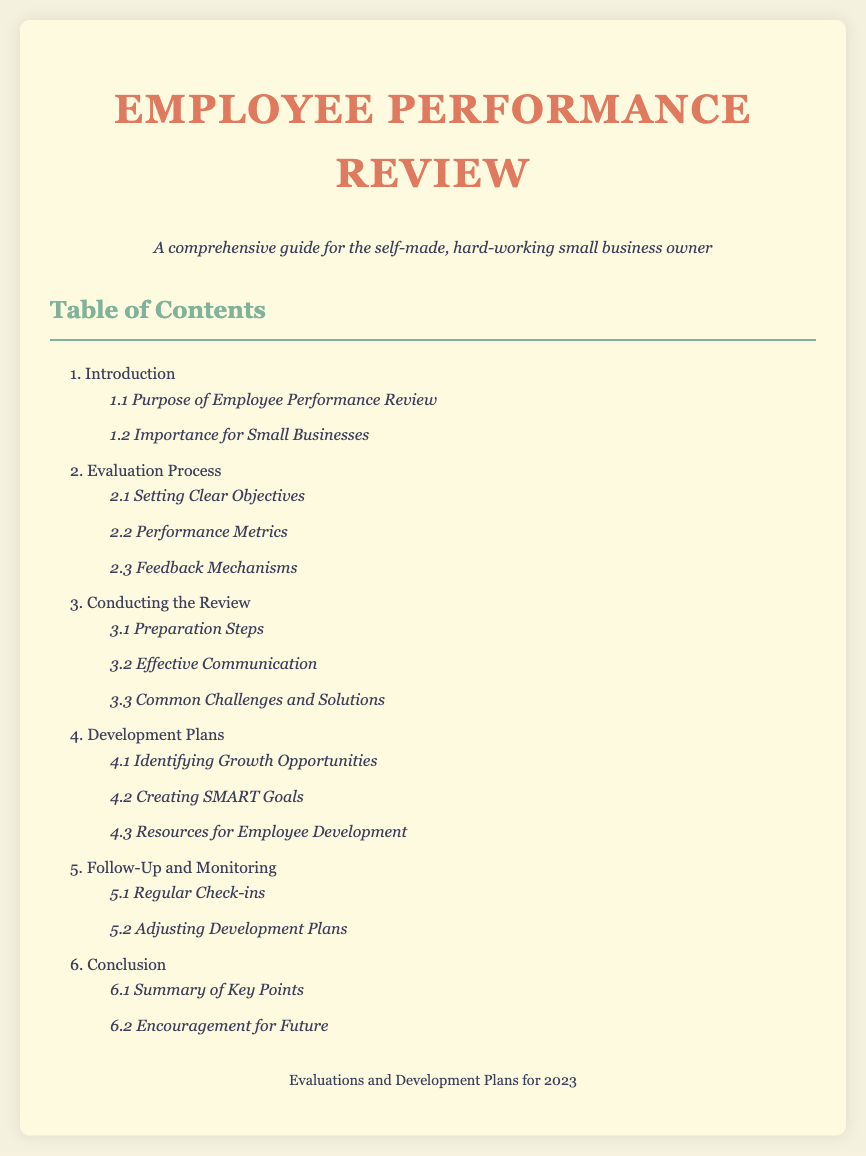What is the title of the document? The title is the first thing mentioned in the document, which describes the main subject.
Answer: Employee Performance Review How many main sections are in the Table of Contents? The main sections are enumerated in the document, which reveals the total count of sections listed.
Answer: 6 What is the purpose of the employee performance review according to section 1.1? The purpose is specifically stated in section 1.1 of the document.
Answer: Purpose of Employee Performance Review Which section discusses performance metrics? The section that covers performance metrics is clearly outlined in the evaluation process.
Answer: 2.2 Performance Metrics What are SMART goals mentioned in section 4.2? SMART goals are part of development plans and are critical for effective planning.
Answer: Creating SMART Goals What is the last main section of the document? The last main section can be identified by the numbering, as it concludes the content.
Answer: 6. Conclusion What does section 5.1 focus on? Section 5.1 is about ongoing evaluations which facilitate the follow-up process.
Answer: Regular Check-ins Which subsection addresses common challenges? The specific subsection about challenges provides insights into potential issues faced during the review.
Answer: 3.3 Common Challenges and Solutions 